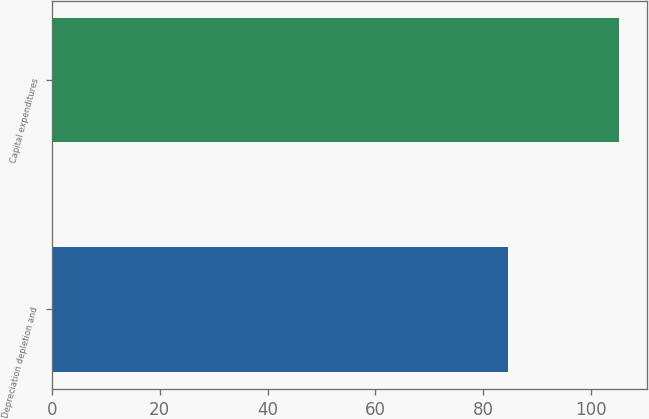<chart> <loc_0><loc_0><loc_500><loc_500><bar_chart><fcel>Depreciation depletion and<fcel>Capital expenditures<nl><fcel>84.5<fcel>105.1<nl></chart> 